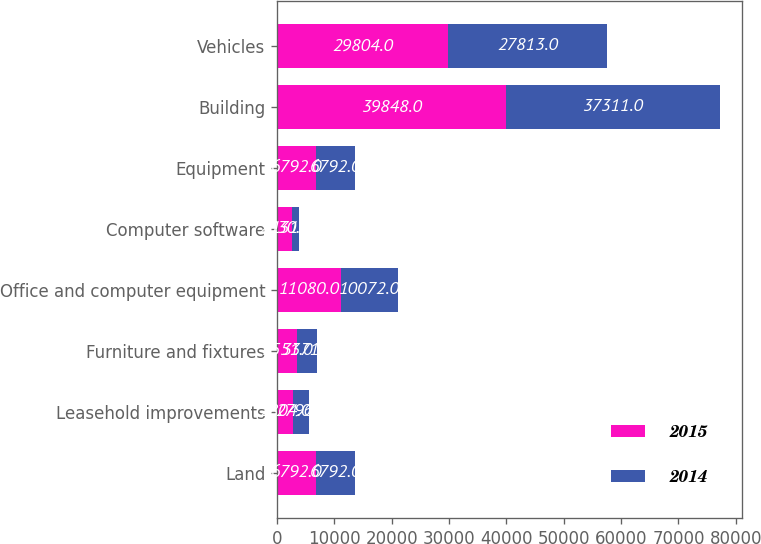Convert chart. <chart><loc_0><loc_0><loc_500><loc_500><stacked_bar_chart><ecel><fcel>Land<fcel>Leasehold improvements<fcel>Furniture and fixtures<fcel>Office and computer equipment<fcel>Computer software<fcel>Equipment<fcel>Building<fcel>Vehicles<nl><fcel>2015<fcel>6792<fcel>2804<fcel>3551<fcel>11080<fcel>2530<fcel>6792<fcel>39848<fcel>29804<nl><fcel>2014<fcel>6792<fcel>2796<fcel>3371<fcel>10072<fcel>1317<fcel>6792<fcel>37311<fcel>27813<nl></chart> 